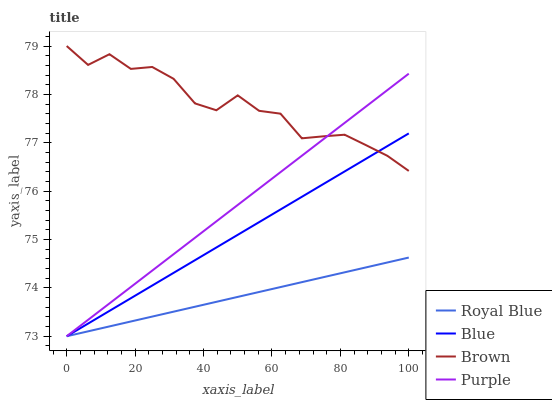Does Royal Blue have the minimum area under the curve?
Answer yes or no. Yes. Does Brown have the maximum area under the curve?
Answer yes or no. Yes. Does Purple have the minimum area under the curve?
Answer yes or no. No. Does Purple have the maximum area under the curve?
Answer yes or no. No. Is Blue the smoothest?
Answer yes or no. Yes. Is Brown the roughest?
Answer yes or no. Yes. Is Royal Blue the smoothest?
Answer yes or no. No. Is Royal Blue the roughest?
Answer yes or no. No. Does Brown have the lowest value?
Answer yes or no. No. Does Purple have the highest value?
Answer yes or no. No. Is Royal Blue less than Brown?
Answer yes or no. Yes. Is Brown greater than Royal Blue?
Answer yes or no. Yes. Does Royal Blue intersect Brown?
Answer yes or no. No. 